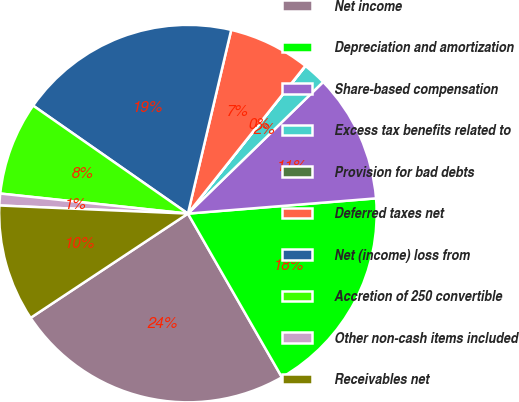Convert chart to OTSL. <chart><loc_0><loc_0><loc_500><loc_500><pie_chart><fcel>Net income<fcel>Depreciation and amortization<fcel>Share-based compensation<fcel>Excess tax benefits related to<fcel>Provision for bad debts<fcel>Deferred taxes net<fcel>Net (income) loss from<fcel>Accretion of 250 convertible<fcel>Other non-cash items included<fcel>Receivables net<nl><fcel>23.98%<fcel>17.99%<fcel>11.0%<fcel>2.01%<fcel>0.02%<fcel>7.0%<fcel>18.99%<fcel>8.0%<fcel>1.01%<fcel>10.0%<nl></chart> 